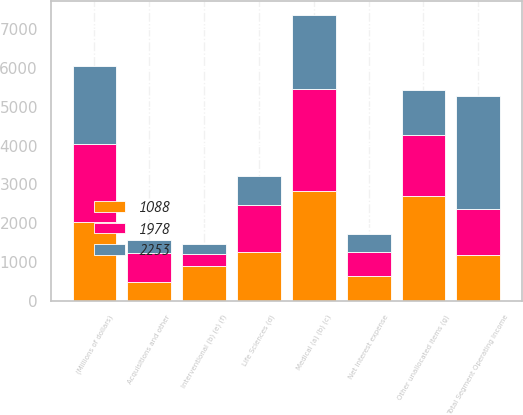Convert chart. <chart><loc_0><loc_0><loc_500><loc_500><stacked_bar_chart><ecel><fcel>(Millions of dollars)<fcel>Medical (a) (b) (c)<fcel>Life Sciences (d)<fcel>Interventional (b) (e) (f)<fcel>Total Segment Operating Income<fcel>Acquisitions and other<fcel>Net interest expense<fcel>Other unallocated items (g)<nl><fcel>1088<fcel>2019<fcel>2824<fcel>1248<fcel>903<fcel>1179.5<fcel>480<fcel>627<fcel>2693<nl><fcel>1978<fcel>2018<fcel>2624<fcel>1207<fcel>306<fcel>1179.5<fcel>740<fcel>641<fcel>1583<nl><fcel>2253<fcel>2017<fcel>1907<fcel>772<fcel>248<fcel>2927<fcel>354<fcel>445<fcel>1152<nl></chart> 